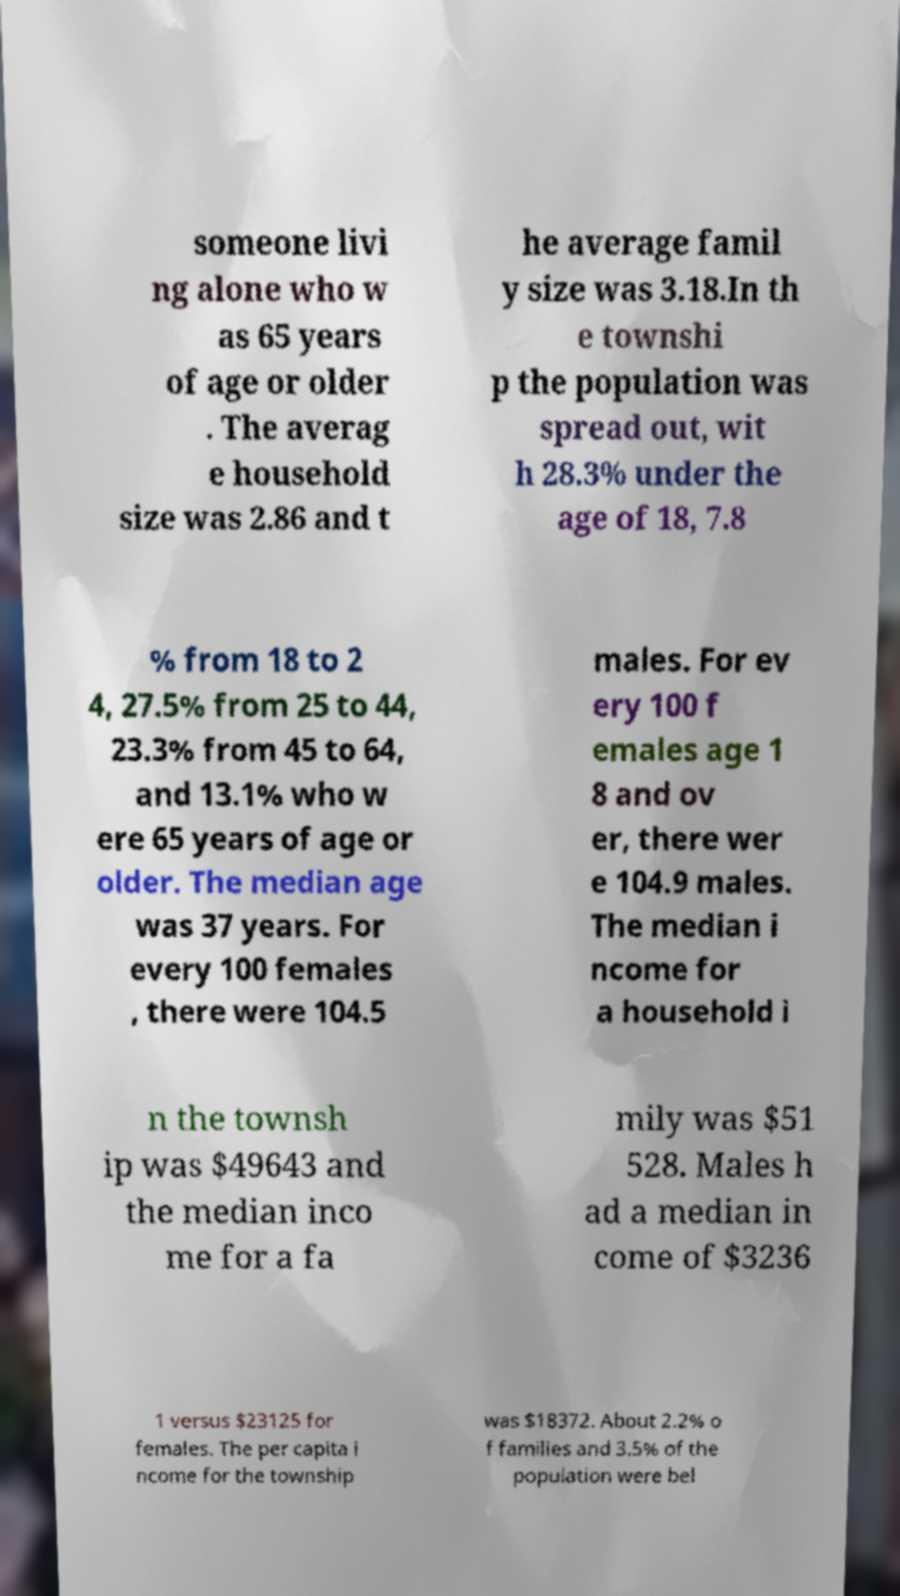Please identify and transcribe the text found in this image. someone livi ng alone who w as 65 years of age or older . The averag e household size was 2.86 and t he average famil y size was 3.18.In th e townshi p the population was spread out, wit h 28.3% under the age of 18, 7.8 % from 18 to 2 4, 27.5% from 25 to 44, 23.3% from 45 to 64, and 13.1% who w ere 65 years of age or older. The median age was 37 years. For every 100 females , there were 104.5 males. For ev ery 100 f emales age 1 8 and ov er, there wer e 104.9 males. The median i ncome for a household i n the townsh ip was $49643 and the median inco me for a fa mily was $51 528. Males h ad a median in come of $3236 1 versus $23125 for females. The per capita i ncome for the township was $18372. About 2.2% o f families and 3.5% of the population were bel 